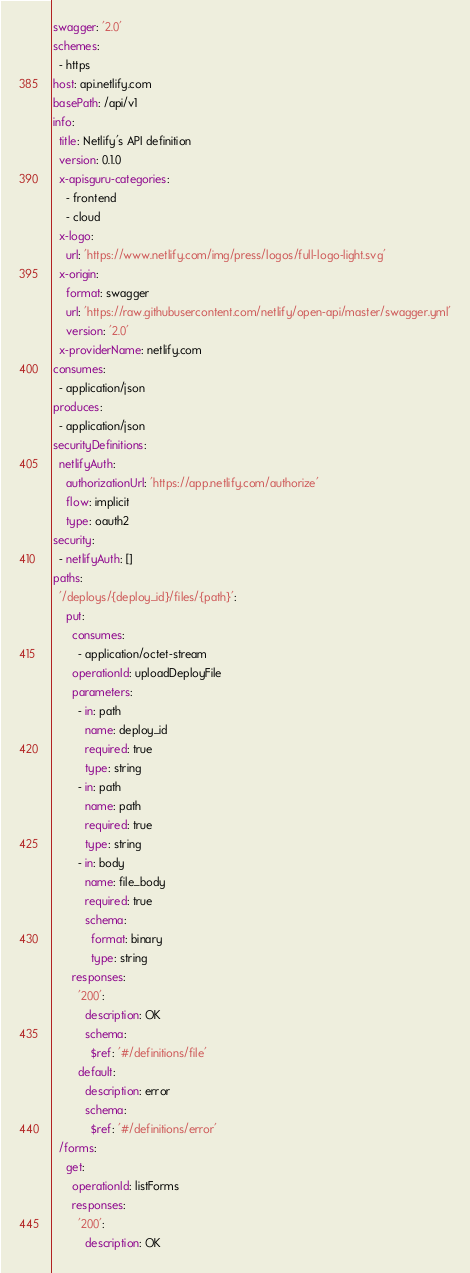Convert code to text. <code><loc_0><loc_0><loc_500><loc_500><_YAML_>swagger: '2.0'
schemes:
  - https
host: api.netlify.com
basePath: /api/v1
info:
  title: Netlify's API definition
  version: 0.1.0
  x-apisguru-categories:
    - frontend
    - cloud
  x-logo:
    url: 'https://www.netlify.com/img/press/logos/full-logo-light.svg'
  x-origin:
    format: swagger
    url: 'https://raw.githubusercontent.com/netlify/open-api/master/swagger.yml'
    version: '2.0'
  x-providerName: netlify.com
consumes:
  - application/json
produces:
  - application/json
securityDefinitions:
  netlifyAuth:
    authorizationUrl: 'https://app.netlify.com/authorize'
    flow: implicit
    type: oauth2
security:
  - netlifyAuth: []
paths:
  '/deploys/{deploy_id}/files/{path}':
    put:
      consumes:
        - application/octet-stream
      operationId: uploadDeployFile
      parameters:
        - in: path
          name: deploy_id
          required: true
          type: string
        - in: path
          name: path
          required: true
          type: string
        - in: body
          name: file_body
          required: true
          schema:
            format: binary
            type: string
      responses:
        '200':
          description: OK
          schema:
            $ref: '#/definitions/file'
        default:
          description: error
          schema:
            $ref: '#/definitions/error'
  /forms:
    get:
      operationId: listForms
      responses:
        '200':
          description: OK</code> 